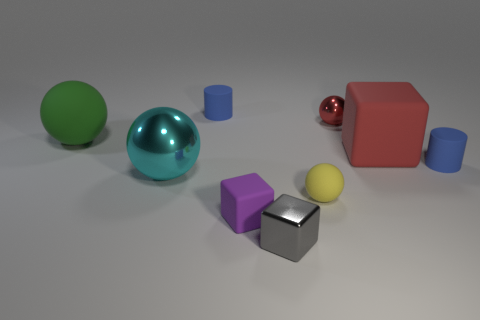Subtract all cubes. How many objects are left? 6 Subtract 0 blue blocks. How many objects are left? 9 Subtract all big spheres. Subtract all large red objects. How many objects are left? 6 Add 3 big cyan objects. How many big cyan objects are left? 4 Add 3 tiny gray objects. How many tiny gray objects exist? 4 